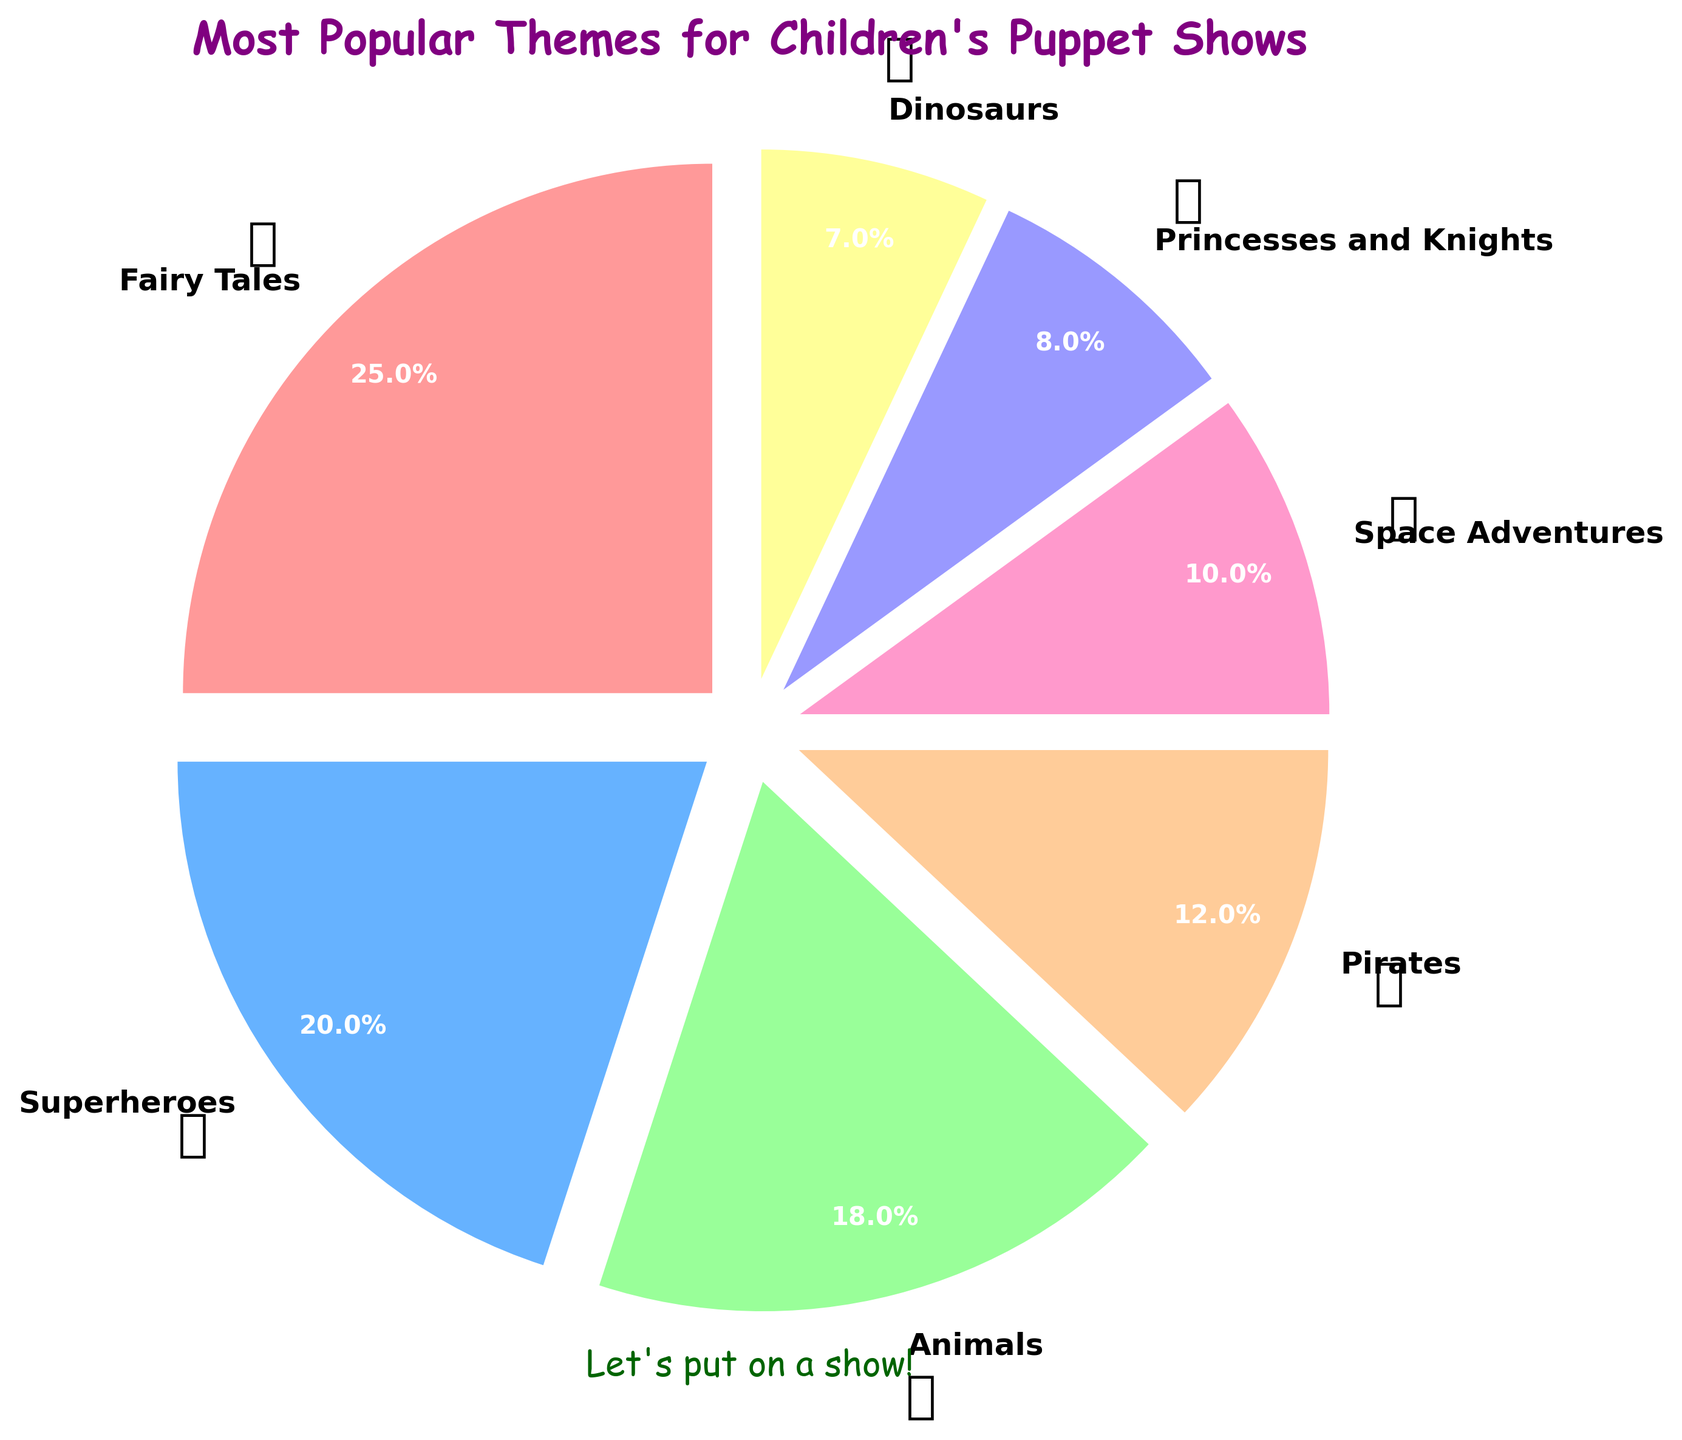Which theme is the most popular in children's puppet shows? According to the pie chart, the Fairy Tales theme takes up the largest portion with 25%.
Answer: Fairy Tales How much more popular are Fairy Tales than Dinosaurs themes? The percentage for Fairy Tales is 25% and for Dinosaurs, it is 7%. Subtracting these gives the difference: 25% - 7% = 18%.
Answer: 18% Which themes have a percentage greater than 15%? From the chart, Fairy Tales (25%), Superheroes (20%), and Animals (18%) are greater than 15%.
Answer: Fairy Tales, Superheroes, Animals Is the Animals theme more or less popular than the Space Adventures theme? The percentage of Animals is 18% and for Space Adventures, it is 10%. Since 18% is greater than 10%, Animals is more popular.
Answer: More popular Which theme has the smallest share in the pie chart? The theme with the smallest percentage in the chart is Dinosaurs with 7%.
Answer: Dinosaurs What's the combined percentage of Pirates and Princesses and Knights themes? Pirates are at 12% and Princesses and Knights are at 8%. Adding these gives: 12% + 8% = 20%.
Answer: 20% If we grouped Pirates and Space Adventures together, what would their combined percentage be? Pirates have 12% and Space Adventures have 10%. Adding these gives: 12% + 10% = 22%.
Answer: 22% What color represents the Superheroes theme in the chart? The chart shows the color representing the Superheroes theme as blue.
Answer: Blue Which two themes combined make up almost half of the puppet shows? Fairy Tales and Superheroes combined make up 25% + 20% = 45%, which is close to half.
Answer: Fairy Tales and Superheroes Are dinosaurs or princesses more popular? Princesses and Knights have 8% while Dinosaurs have 7%. Therefore, Princesses and Knights are more popular.
Answer: Princesses and Knights 